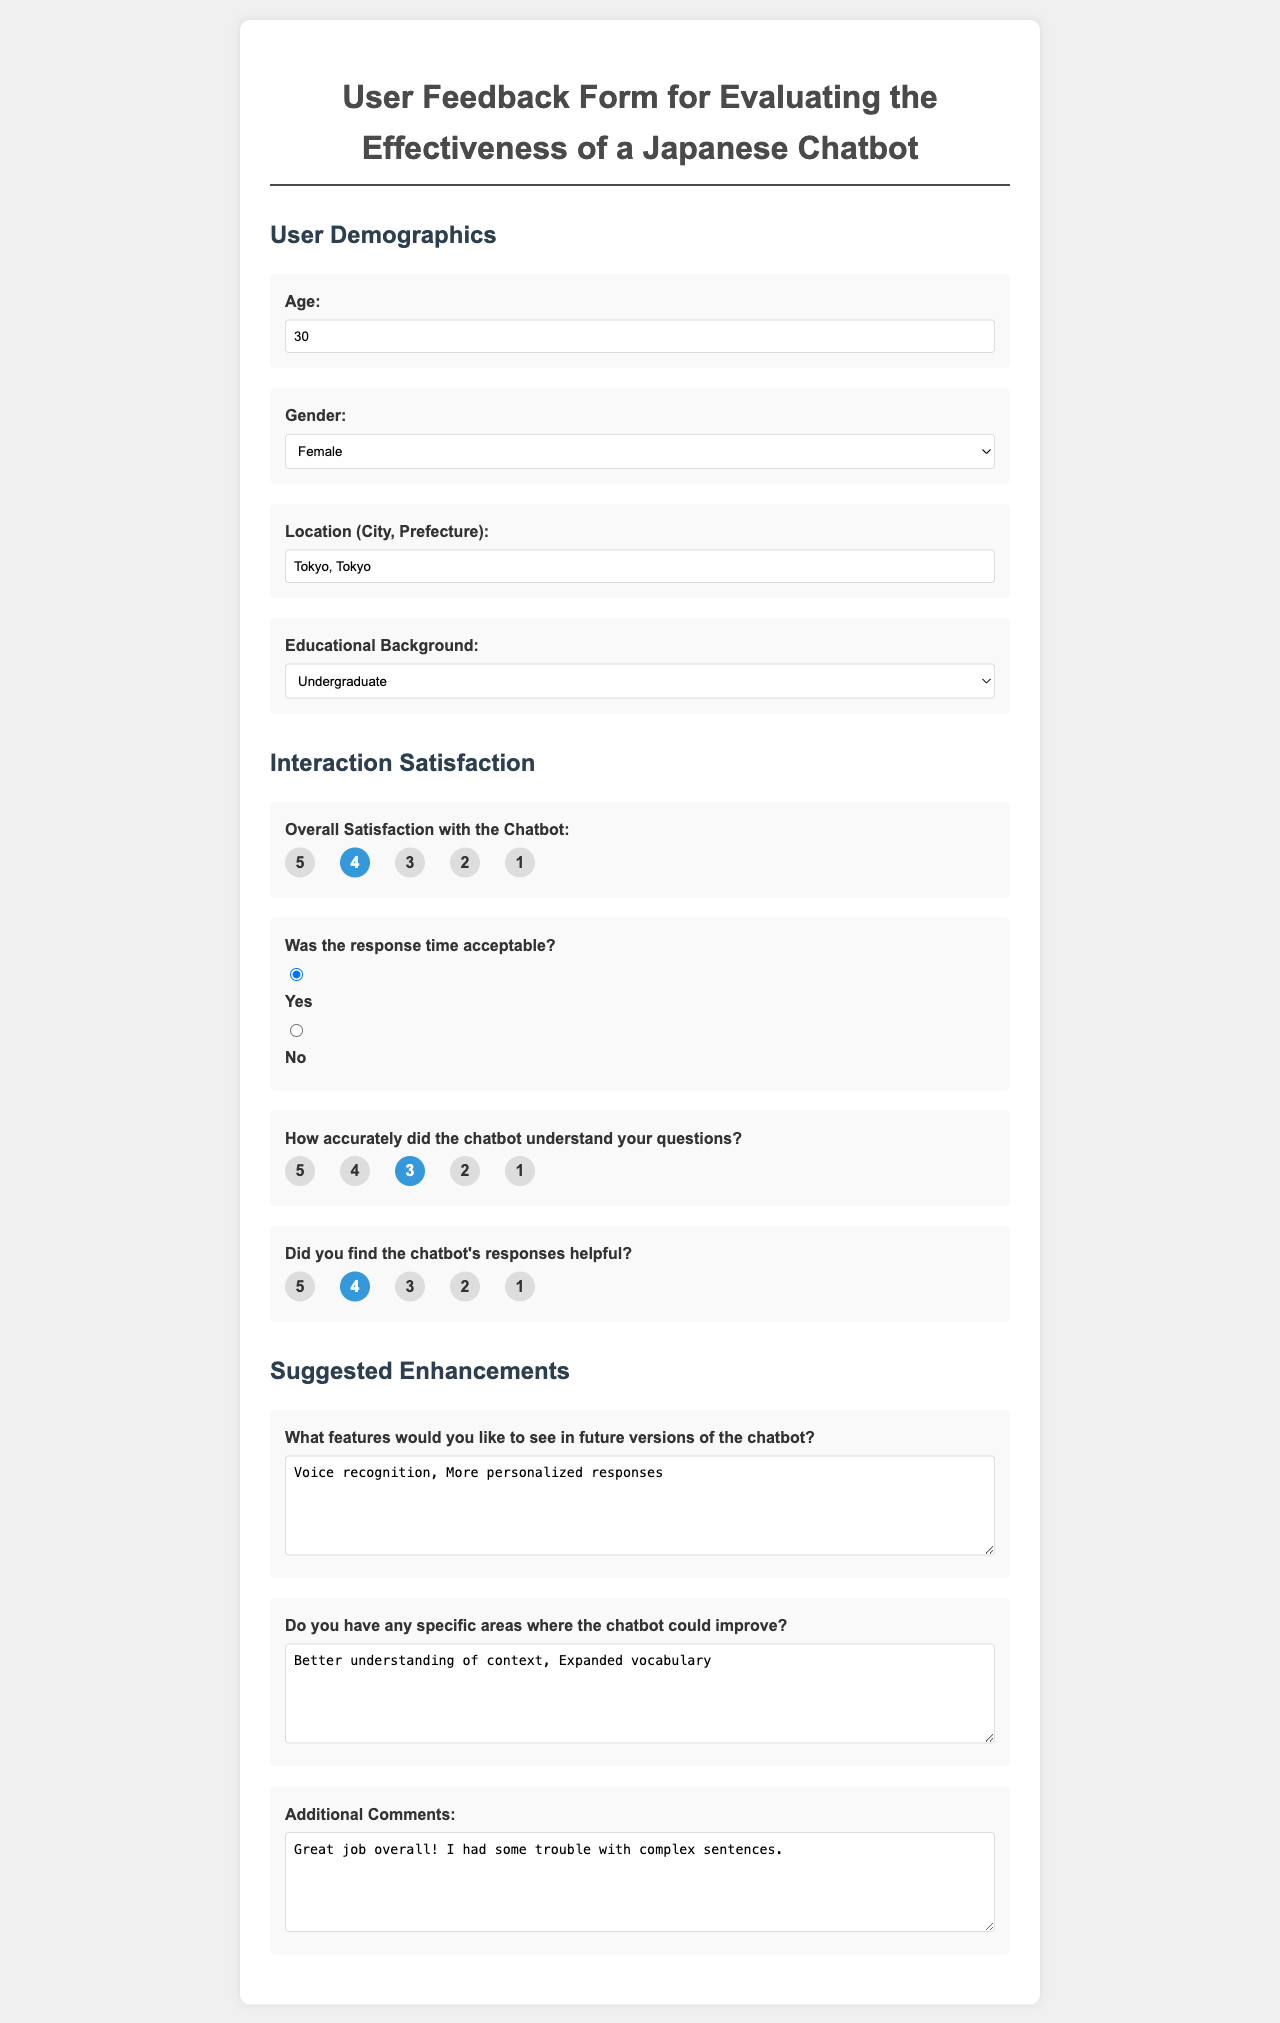What is the age provided in the form? The age input field shows a value of 30.
Answer: 30 What is the selected gender in the feedback form? The gender dropdown has "Female" selected by default.
Answer: Female What city and prefecture is mentioned in the location field? The location input shows "Tokyo, Tokyo".
Answer: Tokyo, Tokyo How satisfied is the user with the chatbot on a scale of 1 to 5? The radio button for satisfaction shows "4" as the checked value.
Answer: 4 Was the response time of the chatbot acceptable according to the feedback? The radio button for "yes" indicating the response time was acceptable is selected.
Answer: Yes What features does the user suggest in future versions of the chatbot? The textarea for features includes "Voice recognition, More personalized responses".
Answer: Voice recognition, More personalized responses In which educational background category does the user fall? The education dropdown has "Undergraduate" selected by default.
Answer: Undergraduate What specific areas does the user think the chatbot could improve? The textarea for improvements mentions "Better understanding of context, Expanded vocabulary".
Answer: Better understanding of context, Expanded vocabulary What additional comment did the user provide about the chatbot? The textarea for additional comments states "Great job overall! I had some trouble with complex sentences."
Answer: Great job overall! I had some trouble with complex sentences 